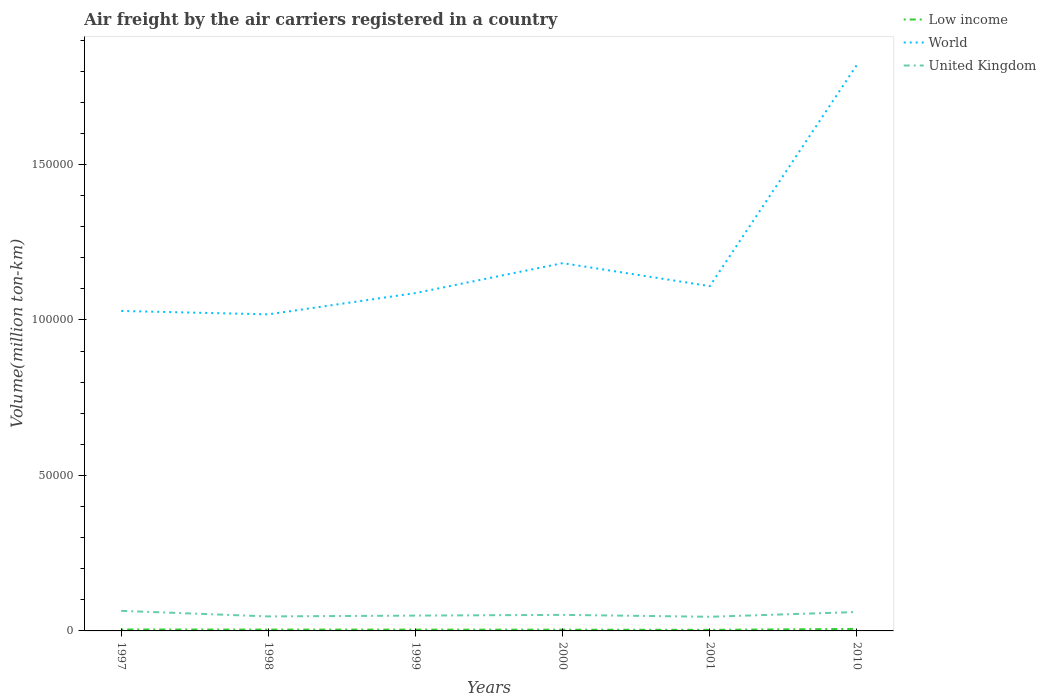Is the number of lines equal to the number of legend labels?
Provide a short and direct response. Yes. Across all years, what is the maximum volume of the air carriers in Low income?
Ensure brevity in your answer.  347.57. What is the total volume of the air carriers in World in the graph?
Your response must be concise. 1087.83. What is the difference between the highest and the second highest volume of the air carriers in United Kingdom?
Offer a very short reply. 1902.05. What is the difference between the highest and the lowest volume of the air carriers in World?
Ensure brevity in your answer.  1. Is the volume of the air carriers in Low income strictly greater than the volume of the air carriers in World over the years?
Your answer should be very brief. Yes. What is the difference between two consecutive major ticks on the Y-axis?
Ensure brevity in your answer.  5.00e+04. Are the values on the major ticks of Y-axis written in scientific E-notation?
Your response must be concise. No. Does the graph contain grids?
Provide a short and direct response. No. Where does the legend appear in the graph?
Your response must be concise. Top right. How many legend labels are there?
Provide a short and direct response. 3. What is the title of the graph?
Offer a terse response. Air freight by the air carriers registered in a country. What is the label or title of the Y-axis?
Give a very brief answer. Volume(million ton-km). What is the Volume(million ton-km) in Low income in 1997?
Keep it short and to the point. 467.3. What is the Volume(million ton-km) in World in 1997?
Provide a short and direct response. 1.03e+05. What is the Volume(million ton-km) in United Kingdom in 1997?
Provide a short and direct response. 6450.6. What is the Volume(million ton-km) in Low income in 1998?
Your response must be concise. 428.1. What is the Volume(million ton-km) of World in 1998?
Provide a succinct answer. 1.02e+05. What is the Volume(million ton-km) of United Kingdom in 1998?
Your answer should be very brief. 4663.5. What is the Volume(million ton-km) in Low income in 1999?
Give a very brief answer. 413.9. What is the Volume(million ton-km) of World in 1999?
Your response must be concise. 1.09e+05. What is the Volume(million ton-km) of United Kingdom in 1999?
Provide a succinct answer. 4925.2. What is the Volume(million ton-km) of Low income in 2000?
Offer a very short reply. 397.56. What is the Volume(million ton-km) in World in 2000?
Give a very brief answer. 1.18e+05. What is the Volume(million ton-km) of United Kingdom in 2000?
Give a very brief answer. 5160.87. What is the Volume(million ton-km) of Low income in 2001?
Provide a short and direct response. 347.57. What is the Volume(million ton-km) of World in 2001?
Ensure brevity in your answer.  1.11e+05. What is the Volume(million ton-km) of United Kingdom in 2001?
Offer a very short reply. 4548.55. What is the Volume(million ton-km) in Low income in 2010?
Provide a succinct answer. 645.72. What is the Volume(million ton-km) of World in 2010?
Offer a terse response. 1.82e+05. What is the Volume(million ton-km) in United Kingdom in 2010?
Provide a succinct answer. 6082.74. Across all years, what is the maximum Volume(million ton-km) of Low income?
Your answer should be compact. 645.72. Across all years, what is the maximum Volume(million ton-km) of World?
Your response must be concise. 1.82e+05. Across all years, what is the maximum Volume(million ton-km) of United Kingdom?
Your answer should be compact. 6450.6. Across all years, what is the minimum Volume(million ton-km) in Low income?
Offer a very short reply. 347.57. Across all years, what is the minimum Volume(million ton-km) of World?
Your answer should be very brief. 1.02e+05. Across all years, what is the minimum Volume(million ton-km) in United Kingdom?
Provide a short and direct response. 4548.55. What is the total Volume(million ton-km) in Low income in the graph?
Offer a terse response. 2700.15. What is the total Volume(million ton-km) of World in the graph?
Keep it short and to the point. 7.24e+05. What is the total Volume(million ton-km) in United Kingdom in the graph?
Provide a short and direct response. 3.18e+04. What is the difference between the Volume(million ton-km) of Low income in 1997 and that in 1998?
Your answer should be compact. 39.2. What is the difference between the Volume(million ton-km) of World in 1997 and that in 1998?
Give a very brief answer. 1087.83. What is the difference between the Volume(million ton-km) of United Kingdom in 1997 and that in 1998?
Your response must be concise. 1787.1. What is the difference between the Volume(million ton-km) in Low income in 1997 and that in 1999?
Your answer should be very brief. 53.4. What is the difference between the Volume(million ton-km) in World in 1997 and that in 1999?
Ensure brevity in your answer.  -5753.52. What is the difference between the Volume(million ton-km) of United Kingdom in 1997 and that in 1999?
Your response must be concise. 1525.4. What is the difference between the Volume(million ton-km) in Low income in 1997 and that in 2000?
Your response must be concise. 69.74. What is the difference between the Volume(million ton-km) in World in 1997 and that in 2000?
Give a very brief answer. -1.54e+04. What is the difference between the Volume(million ton-km) in United Kingdom in 1997 and that in 2000?
Keep it short and to the point. 1289.73. What is the difference between the Volume(million ton-km) in Low income in 1997 and that in 2001?
Your response must be concise. 119.73. What is the difference between the Volume(million ton-km) of World in 1997 and that in 2001?
Your response must be concise. -7984.73. What is the difference between the Volume(million ton-km) in United Kingdom in 1997 and that in 2001?
Give a very brief answer. 1902.05. What is the difference between the Volume(million ton-km) of Low income in 1997 and that in 2010?
Offer a very short reply. -178.42. What is the difference between the Volume(million ton-km) in World in 1997 and that in 2010?
Make the answer very short. -7.91e+04. What is the difference between the Volume(million ton-km) in United Kingdom in 1997 and that in 2010?
Offer a terse response. 367.86. What is the difference between the Volume(million ton-km) of World in 1998 and that in 1999?
Give a very brief answer. -6841.34. What is the difference between the Volume(million ton-km) in United Kingdom in 1998 and that in 1999?
Ensure brevity in your answer.  -261.7. What is the difference between the Volume(million ton-km) of Low income in 1998 and that in 2000?
Your answer should be compact. 30.54. What is the difference between the Volume(million ton-km) of World in 1998 and that in 2000?
Provide a succinct answer. -1.65e+04. What is the difference between the Volume(million ton-km) of United Kingdom in 1998 and that in 2000?
Ensure brevity in your answer.  -497.37. What is the difference between the Volume(million ton-km) of Low income in 1998 and that in 2001?
Make the answer very short. 80.53. What is the difference between the Volume(million ton-km) of World in 1998 and that in 2001?
Your response must be concise. -9072.56. What is the difference between the Volume(million ton-km) of United Kingdom in 1998 and that in 2001?
Provide a short and direct response. 114.95. What is the difference between the Volume(million ton-km) in Low income in 1998 and that in 2010?
Make the answer very short. -217.62. What is the difference between the Volume(million ton-km) of World in 1998 and that in 2010?
Your answer should be very brief. -8.02e+04. What is the difference between the Volume(million ton-km) in United Kingdom in 1998 and that in 2010?
Your response must be concise. -1419.24. What is the difference between the Volume(million ton-km) in Low income in 1999 and that in 2000?
Provide a short and direct response. 16.34. What is the difference between the Volume(million ton-km) of World in 1999 and that in 2000?
Keep it short and to the point. -9627.59. What is the difference between the Volume(million ton-km) in United Kingdom in 1999 and that in 2000?
Provide a short and direct response. -235.67. What is the difference between the Volume(million ton-km) in Low income in 1999 and that in 2001?
Provide a succinct answer. 66.33. What is the difference between the Volume(million ton-km) of World in 1999 and that in 2001?
Offer a very short reply. -2231.22. What is the difference between the Volume(million ton-km) of United Kingdom in 1999 and that in 2001?
Offer a very short reply. 376.65. What is the difference between the Volume(million ton-km) in Low income in 1999 and that in 2010?
Give a very brief answer. -231.82. What is the difference between the Volume(million ton-km) of World in 1999 and that in 2010?
Your answer should be compact. -7.34e+04. What is the difference between the Volume(million ton-km) in United Kingdom in 1999 and that in 2010?
Your answer should be compact. -1157.54. What is the difference between the Volume(million ton-km) in Low income in 2000 and that in 2001?
Offer a terse response. 50. What is the difference between the Volume(million ton-km) in World in 2000 and that in 2001?
Make the answer very short. 7396.38. What is the difference between the Volume(million ton-km) in United Kingdom in 2000 and that in 2001?
Offer a terse response. 612.33. What is the difference between the Volume(million ton-km) in Low income in 2000 and that in 2010?
Ensure brevity in your answer.  -248.16. What is the difference between the Volume(million ton-km) of World in 2000 and that in 2010?
Your answer should be compact. -6.38e+04. What is the difference between the Volume(million ton-km) in United Kingdom in 2000 and that in 2010?
Offer a terse response. -921.87. What is the difference between the Volume(million ton-km) in Low income in 2001 and that in 2010?
Keep it short and to the point. -298.15. What is the difference between the Volume(million ton-km) of World in 2001 and that in 2010?
Offer a very short reply. -7.12e+04. What is the difference between the Volume(million ton-km) in United Kingdom in 2001 and that in 2010?
Offer a terse response. -1534.19. What is the difference between the Volume(million ton-km) of Low income in 1997 and the Volume(million ton-km) of World in 1998?
Provide a succinct answer. -1.01e+05. What is the difference between the Volume(million ton-km) of Low income in 1997 and the Volume(million ton-km) of United Kingdom in 1998?
Make the answer very short. -4196.2. What is the difference between the Volume(million ton-km) of World in 1997 and the Volume(million ton-km) of United Kingdom in 1998?
Your answer should be very brief. 9.82e+04. What is the difference between the Volume(million ton-km) in Low income in 1997 and the Volume(million ton-km) in World in 1999?
Your answer should be compact. -1.08e+05. What is the difference between the Volume(million ton-km) of Low income in 1997 and the Volume(million ton-km) of United Kingdom in 1999?
Offer a terse response. -4457.9. What is the difference between the Volume(million ton-km) of World in 1997 and the Volume(million ton-km) of United Kingdom in 1999?
Give a very brief answer. 9.80e+04. What is the difference between the Volume(million ton-km) of Low income in 1997 and the Volume(million ton-km) of World in 2000?
Offer a terse response. -1.18e+05. What is the difference between the Volume(million ton-km) of Low income in 1997 and the Volume(million ton-km) of United Kingdom in 2000?
Give a very brief answer. -4693.57. What is the difference between the Volume(million ton-km) of World in 1997 and the Volume(million ton-km) of United Kingdom in 2000?
Provide a short and direct response. 9.77e+04. What is the difference between the Volume(million ton-km) of Low income in 1997 and the Volume(million ton-km) of World in 2001?
Keep it short and to the point. -1.10e+05. What is the difference between the Volume(million ton-km) of Low income in 1997 and the Volume(million ton-km) of United Kingdom in 2001?
Your answer should be compact. -4081.25. What is the difference between the Volume(million ton-km) in World in 1997 and the Volume(million ton-km) in United Kingdom in 2001?
Give a very brief answer. 9.83e+04. What is the difference between the Volume(million ton-km) in Low income in 1997 and the Volume(million ton-km) in World in 2010?
Your response must be concise. -1.82e+05. What is the difference between the Volume(million ton-km) of Low income in 1997 and the Volume(million ton-km) of United Kingdom in 2010?
Offer a very short reply. -5615.44. What is the difference between the Volume(million ton-km) of World in 1997 and the Volume(million ton-km) of United Kingdom in 2010?
Make the answer very short. 9.68e+04. What is the difference between the Volume(million ton-km) in Low income in 1998 and the Volume(million ton-km) in World in 1999?
Offer a very short reply. -1.08e+05. What is the difference between the Volume(million ton-km) in Low income in 1998 and the Volume(million ton-km) in United Kingdom in 1999?
Keep it short and to the point. -4497.1. What is the difference between the Volume(million ton-km) in World in 1998 and the Volume(million ton-km) in United Kingdom in 1999?
Ensure brevity in your answer.  9.69e+04. What is the difference between the Volume(million ton-km) in Low income in 1998 and the Volume(million ton-km) in World in 2000?
Offer a terse response. -1.18e+05. What is the difference between the Volume(million ton-km) of Low income in 1998 and the Volume(million ton-km) of United Kingdom in 2000?
Keep it short and to the point. -4732.77. What is the difference between the Volume(million ton-km) of World in 1998 and the Volume(million ton-km) of United Kingdom in 2000?
Provide a short and direct response. 9.66e+04. What is the difference between the Volume(million ton-km) of Low income in 1998 and the Volume(million ton-km) of World in 2001?
Give a very brief answer. -1.10e+05. What is the difference between the Volume(million ton-km) of Low income in 1998 and the Volume(million ton-km) of United Kingdom in 2001?
Give a very brief answer. -4120.45. What is the difference between the Volume(million ton-km) of World in 1998 and the Volume(million ton-km) of United Kingdom in 2001?
Provide a succinct answer. 9.72e+04. What is the difference between the Volume(million ton-km) of Low income in 1998 and the Volume(million ton-km) of World in 2010?
Make the answer very short. -1.82e+05. What is the difference between the Volume(million ton-km) of Low income in 1998 and the Volume(million ton-km) of United Kingdom in 2010?
Give a very brief answer. -5654.64. What is the difference between the Volume(million ton-km) in World in 1998 and the Volume(million ton-km) in United Kingdom in 2010?
Make the answer very short. 9.57e+04. What is the difference between the Volume(million ton-km) of Low income in 1999 and the Volume(million ton-km) of World in 2000?
Give a very brief answer. -1.18e+05. What is the difference between the Volume(million ton-km) of Low income in 1999 and the Volume(million ton-km) of United Kingdom in 2000?
Give a very brief answer. -4746.97. What is the difference between the Volume(million ton-km) in World in 1999 and the Volume(million ton-km) in United Kingdom in 2000?
Provide a succinct answer. 1.03e+05. What is the difference between the Volume(million ton-km) of Low income in 1999 and the Volume(million ton-km) of World in 2001?
Offer a terse response. -1.10e+05. What is the difference between the Volume(million ton-km) in Low income in 1999 and the Volume(million ton-km) in United Kingdom in 2001?
Your response must be concise. -4134.65. What is the difference between the Volume(million ton-km) in World in 1999 and the Volume(million ton-km) in United Kingdom in 2001?
Keep it short and to the point. 1.04e+05. What is the difference between the Volume(million ton-km) in Low income in 1999 and the Volume(million ton-km) in World in 2010?
Your response must be concise. -1.82e+05. What is the difference between the Volume(million ton-km) of Low income in 1999 and the Volume(million ton-km) of United Kingdom in 2010?
Provide a succinct answer. -5668.84. What is the difference between the Volume(million ton-km) in World in 1999 and the Volume(million ton-km) in United Kingdom in 2010?
Your answer should be very brief. 1.03e+05. What is the difference between the Volume(million ton-km) in Low income in 2000 and the Volume(million ton-km) in World in 2001?
Your answer should be very brief. -1.10e+05. What is the difference between the Volume(million ton-km) in Low income in 2000 and the Volume(million ton-km) in United Kingdom in 2001?
Your answer should be very brief. -4150.98. What is the difference between the Volume(million ton-km) in World in 2000 and the Volume(million ton-km) in United Kingdom in 2001?
Provide a short and direct response. 1.14e+05. What is the difference between the Volume(million ton-km) in Low income in 2000 and the Volume(million ton-km) in World in 2010?
Offer a very short reply. -1.82e+05. What is the difference between the Volume(million ton-km) of Low income in 2000 and the Volume(million ton-km) of United Kingdom in 2010?
Make the answer very short. -5685.18. What is the difference between the Volume(million ton-km) of World in 2000 and the Volume(million ton-km) of United Kingdom in 2010?
Offer a terse response. 1.12e+05. What is the difference between the Volume(million ton-km) in Low income in 2001 and the Volume(million ton-km) in World in 2010?
Provide a succinct answer. -1.82e+05. What is the difference between the Volume(million ton-km) of Low income in 2001 and the Volume(million ton-km) of United Kingdom in 2010?
Ensure brevity in your answer.  -5735.17. What is the difference between the Volume(million ton-km) of World in 2001 and the Volume(million ton-km) of United Kingdom in 2010?
Your answer should be very brief. 1.05e+05. What is the average Volume(million ton-km) of Low income per year?
Your response must be concise. 450.02. What is the average Volume(million ton-km) in World per year?
Provide a succinct answer. 1.21e+05. What is the average Volume(million ton-km) in United Kingdom per year?
Your response must be concise. 5305.24. In the year 1997, what is the difference between the Volume(million ton-km) of Low income and Volume(million ton-km) of World?
Ensure brevity in your answer.  -1.02e+05. In the year 1997, what is the difference between the Volume(million ton-km) of Low income and Volume(million ton-km) of United Kingdom?
Keep it short and to the point. -5983.3. In the year 1997, what is the difference between the Volume(million ton-km) of World and Volume(million ton-km) of United Kingdom?
Provide a succinct answer. 9.64e+04. In the year 1998, what is the difference between the Volume(million ton-km) in Low income and Volume(million ton-km) in World?
Offer a very short reply. -1.01e+05. In the year 1998, what is the difference between the Volume(million ton-km) of Low income and Volume(million ton-km) of United Kingdom?
Your response must be concise. -4235.4. In the year 1998, what is the difference between the Volume(million ton-km) of World and Volume(million ton-km) of United Kingdom?
Offer a very short reply. 9.71e+04. In the year 1999, what is the difference between the Volume(million ton-km) in Low income and Volume(million ton-km) in World?
Give a very brief answer. -1.08e+05. In the year 1999, what is the difference between the Volume(million ton-km) of Low income and Volume(million ton-km) of United Kingdom?
Provide a short and direct response. -4511.3. In the year 1999, what is the difference between the Volume(million ton-km) of World and Volume(million ton-km) of United Kingdom?
Offer a very short reply. 1.04e+05. In the year 2000, what is the difference between the Volume(million ton-km) of Low income and Volume(million ton-km) of World?
Your answer should be very brief. -1.18e+05. In the year 2000, what is the difference between the Volume(million ton-km) of Low income and Volume(million ton-km) of United Kingdom?
Give a very brief answer. -4763.31. In the year 2000, what is the difference between the Volume(million ton-km) of World and Volume(million ton-km) of United Kingdom?
Your response must be concise. 1.13e+05. In the year 2001, what is the difference between the Volume(million ton-km) of Low income and Volume(million ton-km) of World?
Offer a terse response. -1.11e+05. In the year 2001, what is the difference between the Volume(million ton-km) in Low income and Volume(million ton-km) in United Kingdom?
Offer a very short reply. -4200.98. In the year 2001, what is the difference between the Volume(million ton-km) of World and Volume(million ton-km) of United Kingdom?
Give a very brief answer. 1.06e+05. In the year 2010, what is the difference between the Volume(million ton-km) of Low income and Volume(million ton-km) of World?
Your answer should be compact. -1.81e+05. In the year 2010, what is the difference between the Volume(million ton-km) of Low income and Volume(million ton-km) of United Kingdom?
Give a very brief answer. -5437.02. In the year 2010, what is the difference between the Volume(million ton-km) of World and Volume(million ton-km) of United Kingdom?
Keep it short and to the point. 1.76e+05. What is the ratio of the Volume(million ton-km) in Low income in 1997 to that in 1998?
Your response must be concise. 1.09. What is the ratio of the Volume(million ton-km) of World in 1997 to that in 1998?
Your answer should be compact. 1.01. What is the ratio of the Volume(million ton-km) in United Kingdom in 1997 to that in 1998?
Your answer should be compact. 1.38. What is the ratio of the Volume(million ton-km) of Low income in 1997 to that in 1999?
Ensure brevity in your answer.  1.13. What is the ratio of the Volume(million ton-km) of World in 1997 to that in 1999?
Provide a short and direct response. 0.95. What is the ratio of the Volume(million ton-km) in United Kingdom in 1997 to that in 1999?
Give a very brief answer. 1.31. What is the ratio of the Volume(million ton-km) in Low income in 1997 to that in 2000?
Keep it short and to the point. 1.18. What is the ratio of the Volume(million ton-km) of World in 1997 to that in 2000?
Provide a succinct answer. 0.87. What is the ratio of the Volume(million ton-km) in United Kingdom in 1997 to that in 2000?
Make the answer very short. 1.25. What is the ratio of the Volume(million ton-km) of Low income in 1997 to that in 2001?
Ensure brevity in your answer.  1.34. What is the ratio of the Volume(million ton-km) in World in 1997 to that in 2001?
Offer a very short reply. 0.93. What is the ratio of the Volume(million ton-km) of United Kingdom in 1997 to that in 2001?
Your answer should be compact. 1.42. What is the ratio of the Volume(million ton-km) in Low income in 1997 to that in 2010?
Your answer should be compact. 0.72. What is the ratio of the Volume(million ton-km) of World in 1997 to that in 2010?
Keep it short and to the point. 0.57. What is the ratio of the Volume(million ton-km) of United Kingdom in 1997 to that in 2010?
Ensure brevity in your answer.  1.06. What is the ratio of the Volume(million ton-km) of Low income in 1998 to that in 1999?
Keep it short and to the point. 1.03. What is the ratio of the Volume(million ton-km) in World in 1998 to that in 1999?
Offer a terse response. 0.94. What is the ratio of the Volume(million ton-km) in United Kingdom in 1998 to that in 1999?
Your answer should be compact. 0.95. What is the ratio of the Volume(million ton-km) in Low income in 1998 to that in 2000?
Make the answer very short. 1.08. What is the ratio of the Volume(million ton-km) of World in 1998 to that in 2000?
Make the answer very short. 0.86. What is the ratio of the Volume(million ton-km) of United Kingdom in 1998 to that in 2000?
Offer a terse response. 0.9. What is the ratio of the Volume(million ton-km) in Low income in 1998 to that in 2001?
Give a very brief answer. 1.23. What is the ratio of the Volume(million ton-km) in World in 1998 to that in 2001?
Provide a succinct answer. 0.92. What is the ratio of the Volume(million ton-km) in United Kingdom in 1998 to that in 2001?
Provide a short and direct response. 1.03. What is the ratio of the Volume(million ton-km) of Low income in 1998 to that in 2010?
Make the answer very short. 0.66. What is the ratio of the Volume(million ton-km) in World in 1998 to that in 2010?
Offer a very short reply. 0.56. What is the ratio of the Volume(million ton-km) of United Kingdom in 1998 to that in 2010?
Give a very brief answer. 0.77. What is the ratio of the Volume(million ton-km) in Low income in 1999 to that in 2000?
Ensure brevity in your answer.  1.04. What is the ratio of the Volume(million ton-km) of World in 1999 to that in 2000?
Your response must be concise. 0.92. What is the ratio of the Volume(million ton-km) in United Kingdom in 1999 to that in 2000?
Offer a very short reply. 0.95. What is the ratio of the Volume(million ton-km) in Low income in 1999 to that in 2001?
Provide a succinct answer. 1.19. What is the ratio of the Volume(million ton-km) of World in 1999 to that in 2001?
Your answer should be compact. 0.98. What is the ratio of the Volume(million ton-km) in United Kingdom in 1999 to that in 2001?
Your answer should be very brief. 1.08. What is the ratio of the Volume(million ton-km) in Low income in 1999 to that in 2010?
Give a very brief answer. 0.64. What is the ratio of the Volume(million ton-km) of World in 1999 to that in 2010?
Provide a succinct answer. 0.6. What is the ratio of the Volume(million ton-km) of United Kingdom in 1999 to that in 2010?
Offer a very short reply. 0.81. What is the ratio of the Volume(million ton-km) of Low income in 2000 to that in 2001?
Offer a very short reply. 1.14. What is the ratio of the Volume(million ton-km) in World in 2000 to that in 2001?
Your response must be concise. 1.07. What is the ratio of the Volume(million ton-km) of United Kingdom in 2000 to that in 2001?
Your response must be concise. 1.13. What is the ratio of the Volume(million ton-km) in Low income in 2000 to that in 2010?
Your answer should be very brief. 0.62. What is the ratio of the Volume(million ton-km) in World in 2000 to that in 2010?
Ensure brevity in your answer.  0.65. What is the ratio of the Volume(million ton-km) in United Kingdom in 2000 to that in 2010?
Your answer should be very brief. 0.85. What is the ratio of the Volume(million ton-km) of Low income in 2001 to that in 2010?
Give a very brief answer. 0.54. What is the ratio of the Volume(million ton-km) of World in 2001 to that in 2010?
Make the answer very short. 0.61. What is the ratio of the Volume(million ton-km) of United Kingdom in 2001 to that in 2010?
Ensure brevity in your answer.  0.75. What is the difference between the highest and the second highest Volume(million ton-km) in Low income?
Your answer should be compact. 178.42. What is the difference between the highest and the second highest Volume(million ton-km) in World?
Give a very brief answer. 6.38e+04. What is the difference between the highest and the second highest Volume(million ton-km) in United Kingdom?
Provide a succinct answer. 367.86. What is the difference between the highest and the lowest Volume(million ton-km) in Low income?
Your answer should be compact. 298.15. What is the difference between the highest and the lowest Volume(million ton-km) of World?
Keep it short and to the point. 8.02e+04. What is the difference between the highest and the lowest Volume(million ton-km) of United Kingdom?
Keep it short and to the point. 1902.05. 